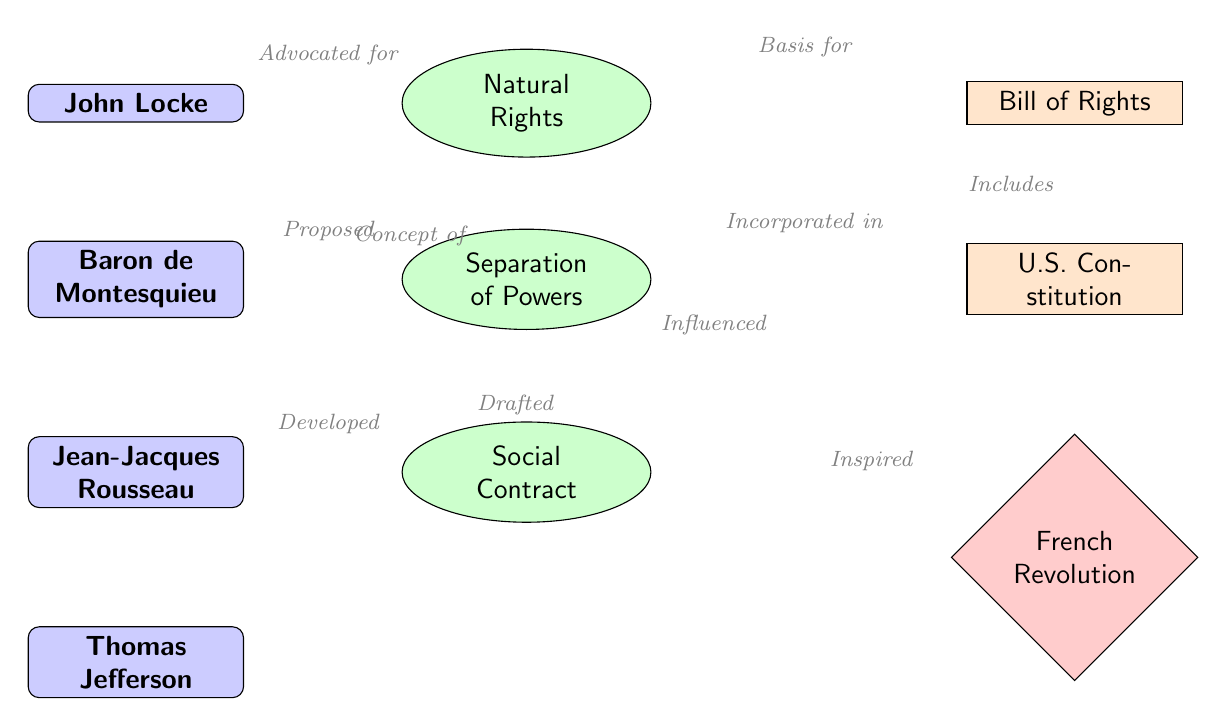What thinker advocated for natural rights? Looking at the diagram, "John Locke" is connected to "Natural Rights" with the label "Advocated for". This indicates that he is the thinker behind the concept of natural rights.
Answer: John Locke How many concepts are presented in the diagram? The diagram shows three concepts: "Natural Rights", "Separation of Powers", and "Social Contract". Counting these gives us a total of three concepts.
Answer: 3 Who developed the social contract? The arrow leads from "Jean-Jacques Rousseau" to "Social Contract" with the label "Developed". This indicates that Rousseau is the individual associated with the development of that concept.
Answer: Jean-Jacques Rousseau Which document is influenced by the social contract? The diagram shows an arrow from "Social Contract" to "U.S. Constitution" labeled "Influenced". This indicates that the U.S. Constitution is the document influenced by the social contract concept.
Answer: U.S. Constitution What event was inspired by the social contract? In the diagram, there is a connection from "Social Contract" to "French Revolution" with the label "Inspired". This indicates the relationship that the social contract concept had with the French Revolution.
Answer: French Revolution Which thinker drafted the U.S. Constitution? The diagram indicates a direct connection from "Thomas Jefferson" to "U.S. Constitution" with the label "Drafted". Thus, it identifies Jefferson as the key figure in drafting this foundational document.
Answer: Thomas Jefferson What concept is the basis for the Bill of Rights? The diagram shows that "Natural Rights" has a relationship with "Bill of Rights" indicated by the label "Basis for". This signifies that natural rights serve as the foundation for the Bill of Rights.
Answer: Natural Rights How are natural rights related to the U.S. Constitution? The connection shown in the diagram is from "Natural Rights" to "Bill of Rights", and further to "U.S. Constitution". Since the Bill of Rights is part of the U.S. Constitution, we can deduce that natural rights feed into this document through the Bill of Rights.
Answer: Through the Bill of Rights What is the relationship between Montesquieu and separation of powers? The edge between "Baron de Montesquieu" and "Separation of Powers" is labeled "Proposed". This implies that Montesquieu is the thinker who proposed the concept of separation of powers in governance.
Answer: Proposed 